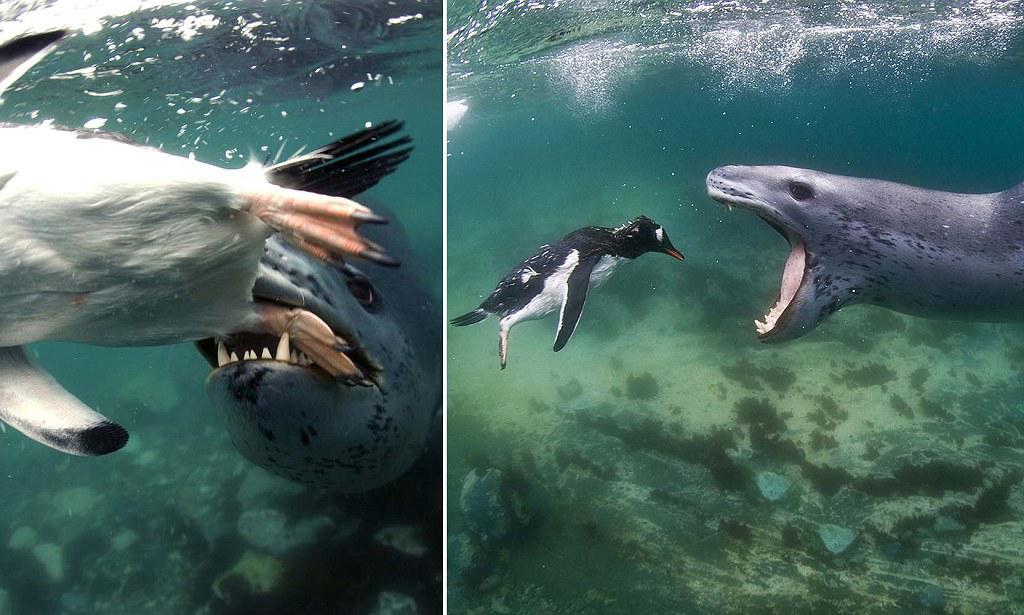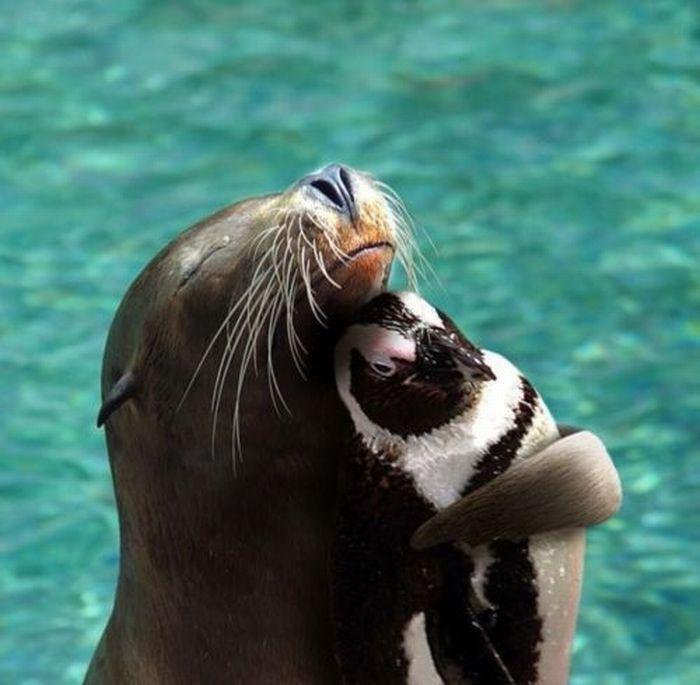The first image is the image on the left, the second image is the image on the right. Considering the images on both sides, is "One of the images in the pair contains a lone seal without any penguins." valid? Answer yes or no. No. The first image is the image on the left, the second image is the image on the right. Evaluate the accuracy of this statement regarding the images: "a seal with a mouth wide open is trying to catch a penguin". Is it true? Answer yes or no. Yes. 